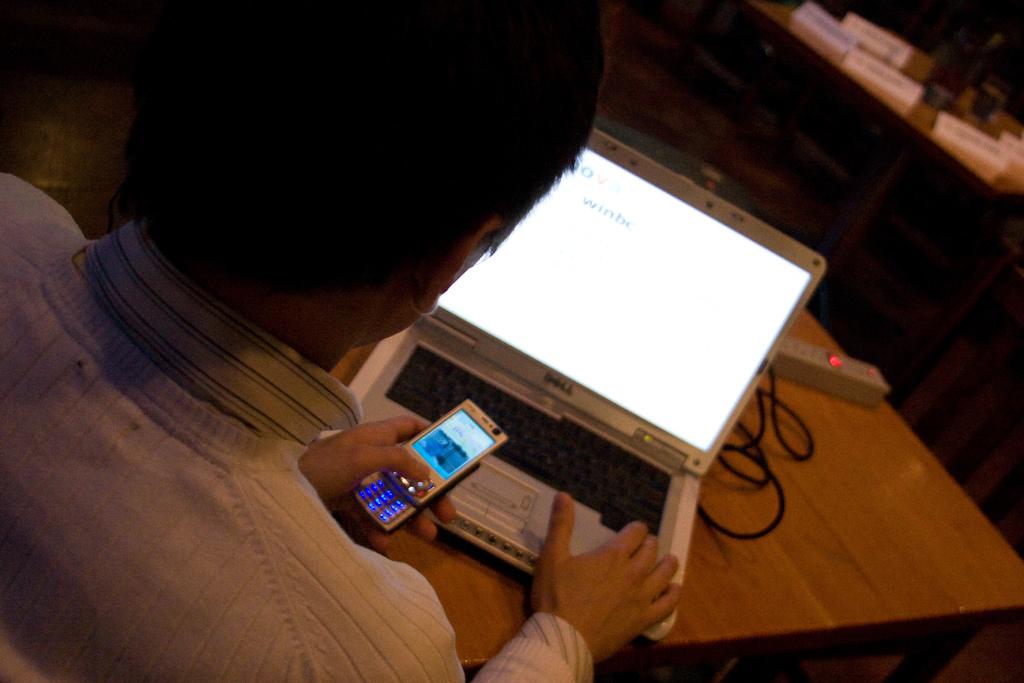Brand name of this laptop?
Provide a succinct answer. Dell. What does the computer screen say?
Your answer should be compact. Winbc. 